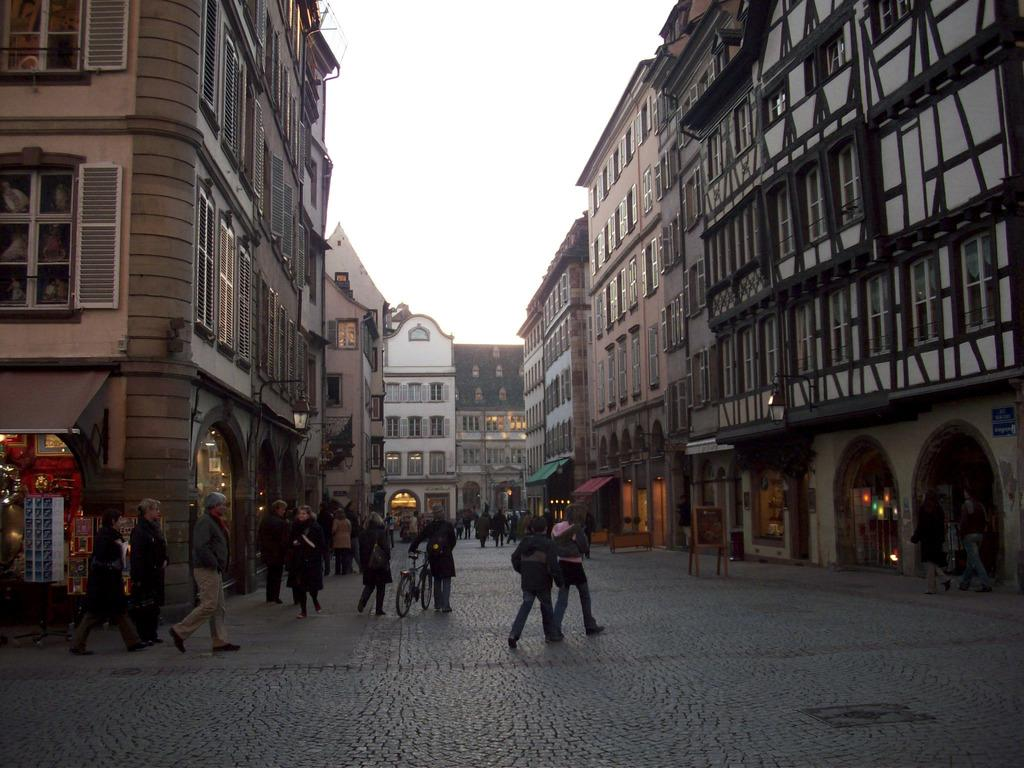What is happening in the image? There is a group of people in the image, and they are walking on a road. What can be seen in the background of the image? There are buildings in the background of the image, and they are in white and brown colors. What is the color of the sky in the image? The sky is visible in the background of the image, and it is white in color. What type of crime is being committed by the people in the image? There is no indication of any crime being committed in the image; the people are simply walking on a road. Can you tell me how many credit cards are visible in the image? There are no credit cards visible in the image. 